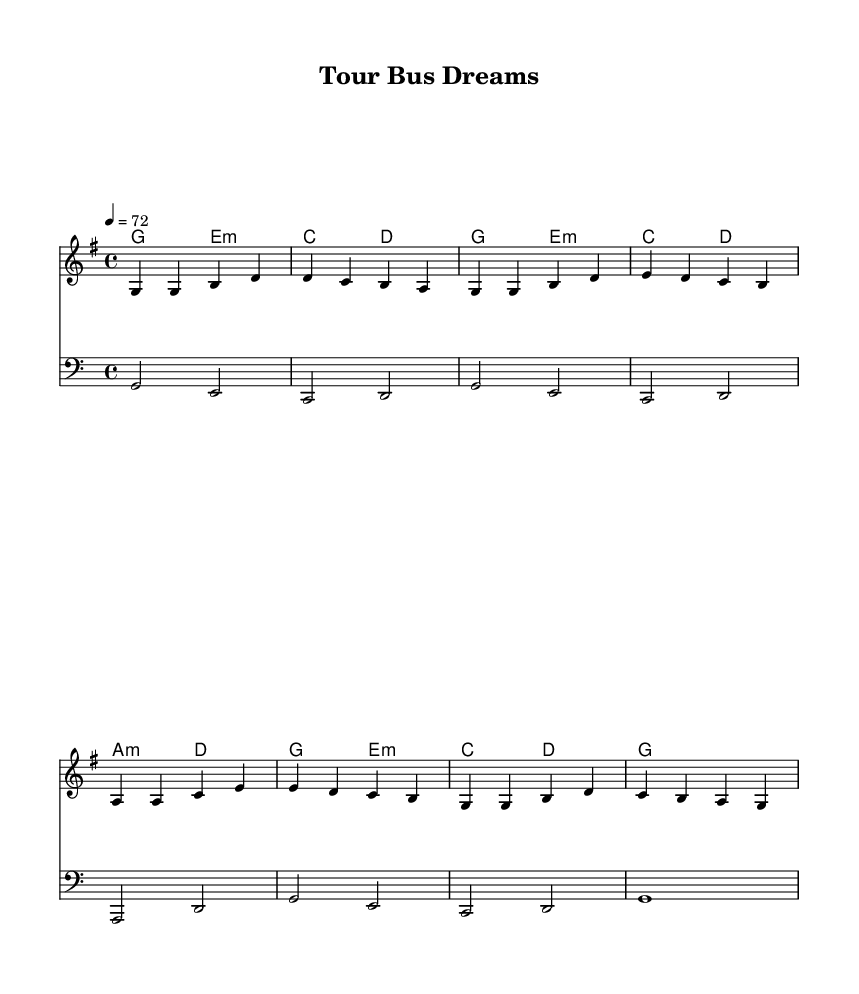What is the key signature of this music? The key signature displayed in the music indicates it is in G major, which has one sharp (F#). This can be seen at the beginning of the staff.
Answer: G major What is the time signature of this piece? The time signature given at the start of the music is 4/4, which means there are four beats in each measure and the quarter note gets one beat. This information is found right after the key signature.
Answer: 4/4 What is the tempo marking? The tempo is marked as 4 = 72, indicating that there are 72 quarter notes per minute. This is usually found at the beginning of the score immediately following the time signature.
Answer: 72 How many measures are in the melody? The melody consists of 8 measures, which can be counted by looking at the grouping of notes and bars throughout the staff. Each bar line separates each measure, and counting them gives a total of 8.
Answer: 8 What is the repeat structure of the chorus? The chorus is structured in a way that it has two repeated phrases, which can be deduced from the lyrics that follow the melody and the overall flow of the musical form that often includes repetition in pop ballads. Specifically, the line "First concert memories replay" indicates a sentiment likely repeated in live performance.
Answer: Two phrases What type of song is represented here? This song is described as a nostalgic pop ballad, as suggested by the lyrics that reminisce about first concert experiences and following dreams, characteristic of pop storytelling. The use of emotional lyrics and a soft melody align with this genre.
Answer: Nostalgic pop ballad What are the primary chords used in this piece? The primary chords indicated in the harmonies are G, E minor, C, D, and A minor. These chords combine to form the harmonic foundation of the piece and are common in pop music to evoke emotional resonance.
Answer: G, E minor, C, D, A minor 